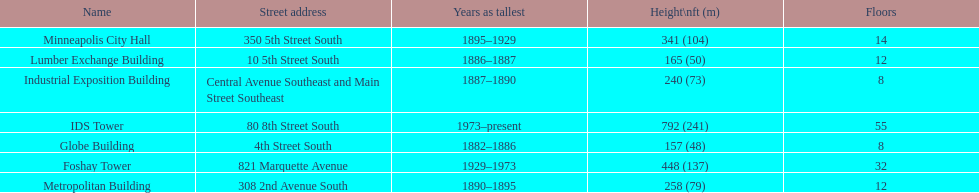How tall is it to the top of the ids tower in feet? 792. 